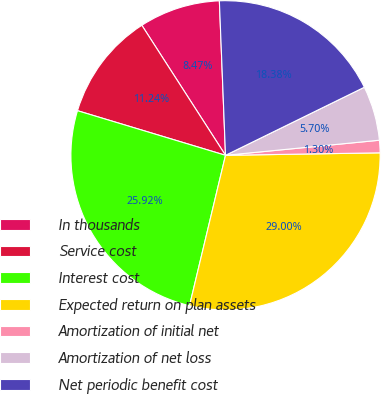Convert chart to OTSL. <chart><loc_0><loc_0><loc_500><loc_500><pie_chart><fcel>In thousands<fcel>Service cost<fcel>Interest cost<fcel>Expected return on plan assets<fcel>Amortization of initial net<fcel>Amortization of net loss<fcel>Net periodic benefit cost<nl><fcel>8.47%<fcel>11.24%<fcel>25.92%<fcel>29.0%<fcel>1.3%<fcel>5.7%<fcel>18.38%<nl></chart> 